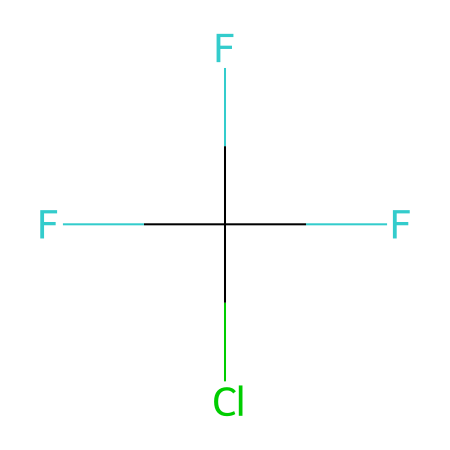What is the name of this chemical? The provided SMILES representation corresponds to a chlorofluorocarbon (CFC) known as trichlorofluoromethane, commonly referred to as CFC-13 or Freon-13. CFCs are recognized for their application as refrigerants.
Answer: CFC-13 How many carbon atoms are in this structure? In the SMILES code, "C" represents a carbon atom. The only "C" in the structure indicates that there is a single carbon atom in this chemical.
Answer: 1 What is the total number of chlorine atoms present? The SMILES code contains "Cl," indicating the presence of chlorine. The code has one instance of "Cl," indicating there is one chlorine atom in this chemical.
Answer: 1 What functional group is present in this refrigerant? The presence of carbon and halogen atoms (fluorine and chlorine) indicates that this chemical belongs to the functional group known as halocarbons, specifically chlorofluorocarbons.
Answer: halocarbon How many fluorine atoms are in this molecule? The notation "F" in the SMILES indicates fluorine atoms. There are three instances of "F" in the representation, which means there are three fluorine atoms in the structure.
Answer: 3 What is the potential environmental impact of this refrigerant? Chlorofluorocarbons like this one contribute to ozone depletion when they are released into the atmosphere, as they can break down ozone molecules in the stratosphere.
Answer: ozone depletion What state of matter is this refrigerant likely to be at room temperature? CFCs are typically gaseous at room temperature; however, their ability to exist as liquids or gases depends on the conditions. For CFC-13, it is commonly found in the gaseous state under standard temperature and pressure.
Answer: gas 